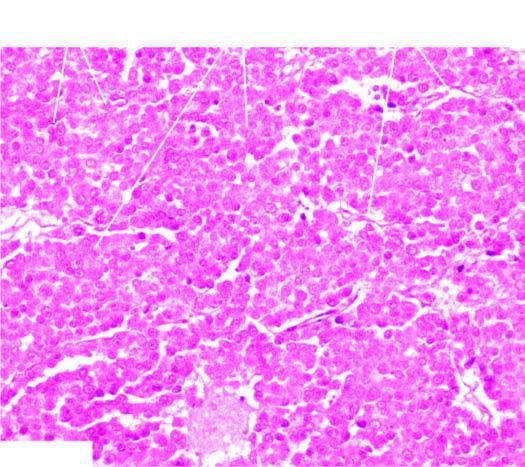re the lumen separated by scanty fibrous stroma that is infiltrated by lymphocytes?
Answer the question using a single word or phrase. No 